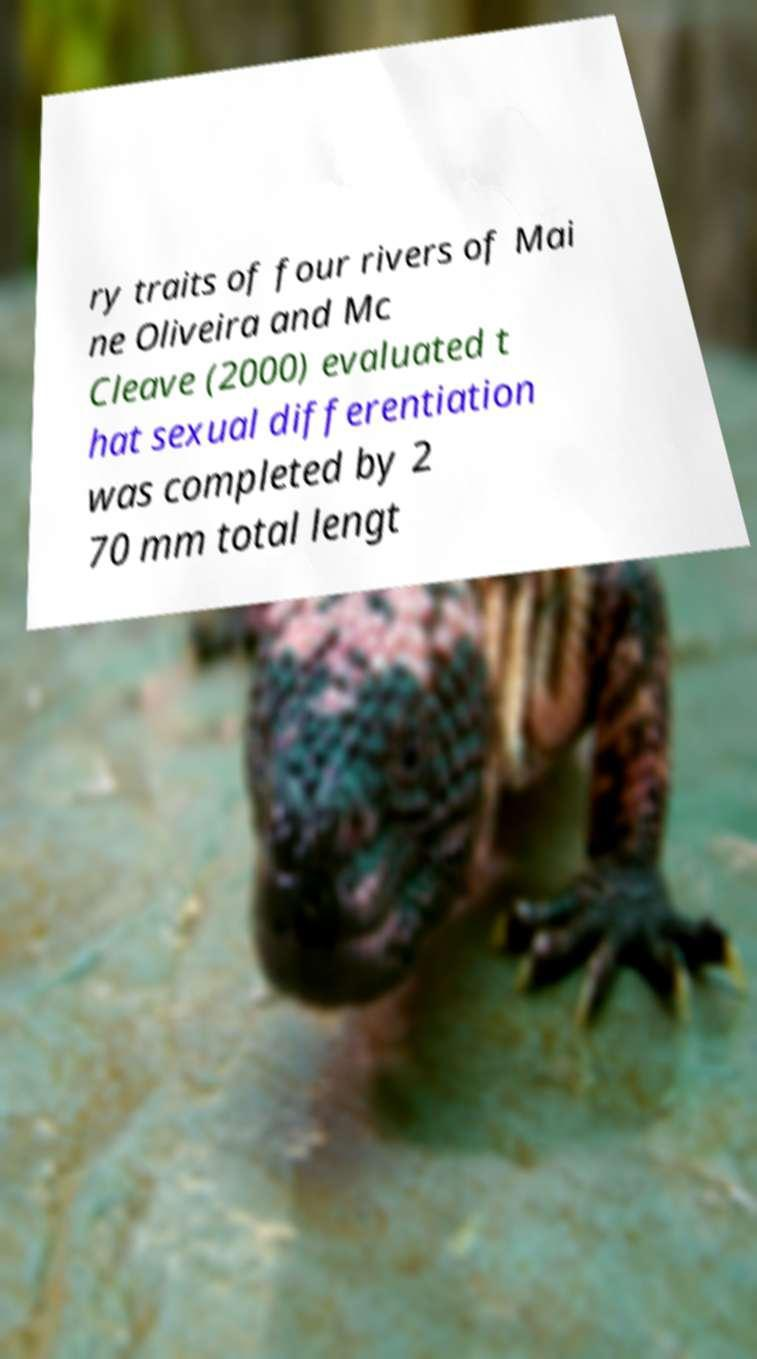Could you assist in decoding the text presented in this image and type it out clearly? ry traits of four rivers of Mai ne Oliveira and Mc Cleave (2000) evaluated t hat sexual differentiation was completed by 2 70 mm total lengt 